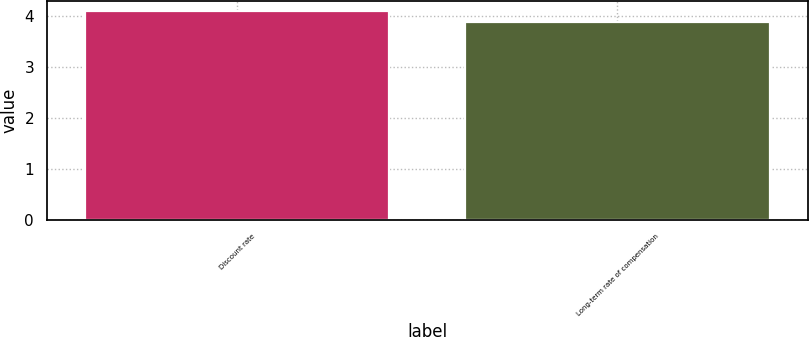<chart> <loc_0><loc_0><loc_500><loc_500><bar_chart><fcel>Discount rate<fcel>Long-term rate of compensation<nl><fcel>4.1<fcel>3.9<nl></chart> 